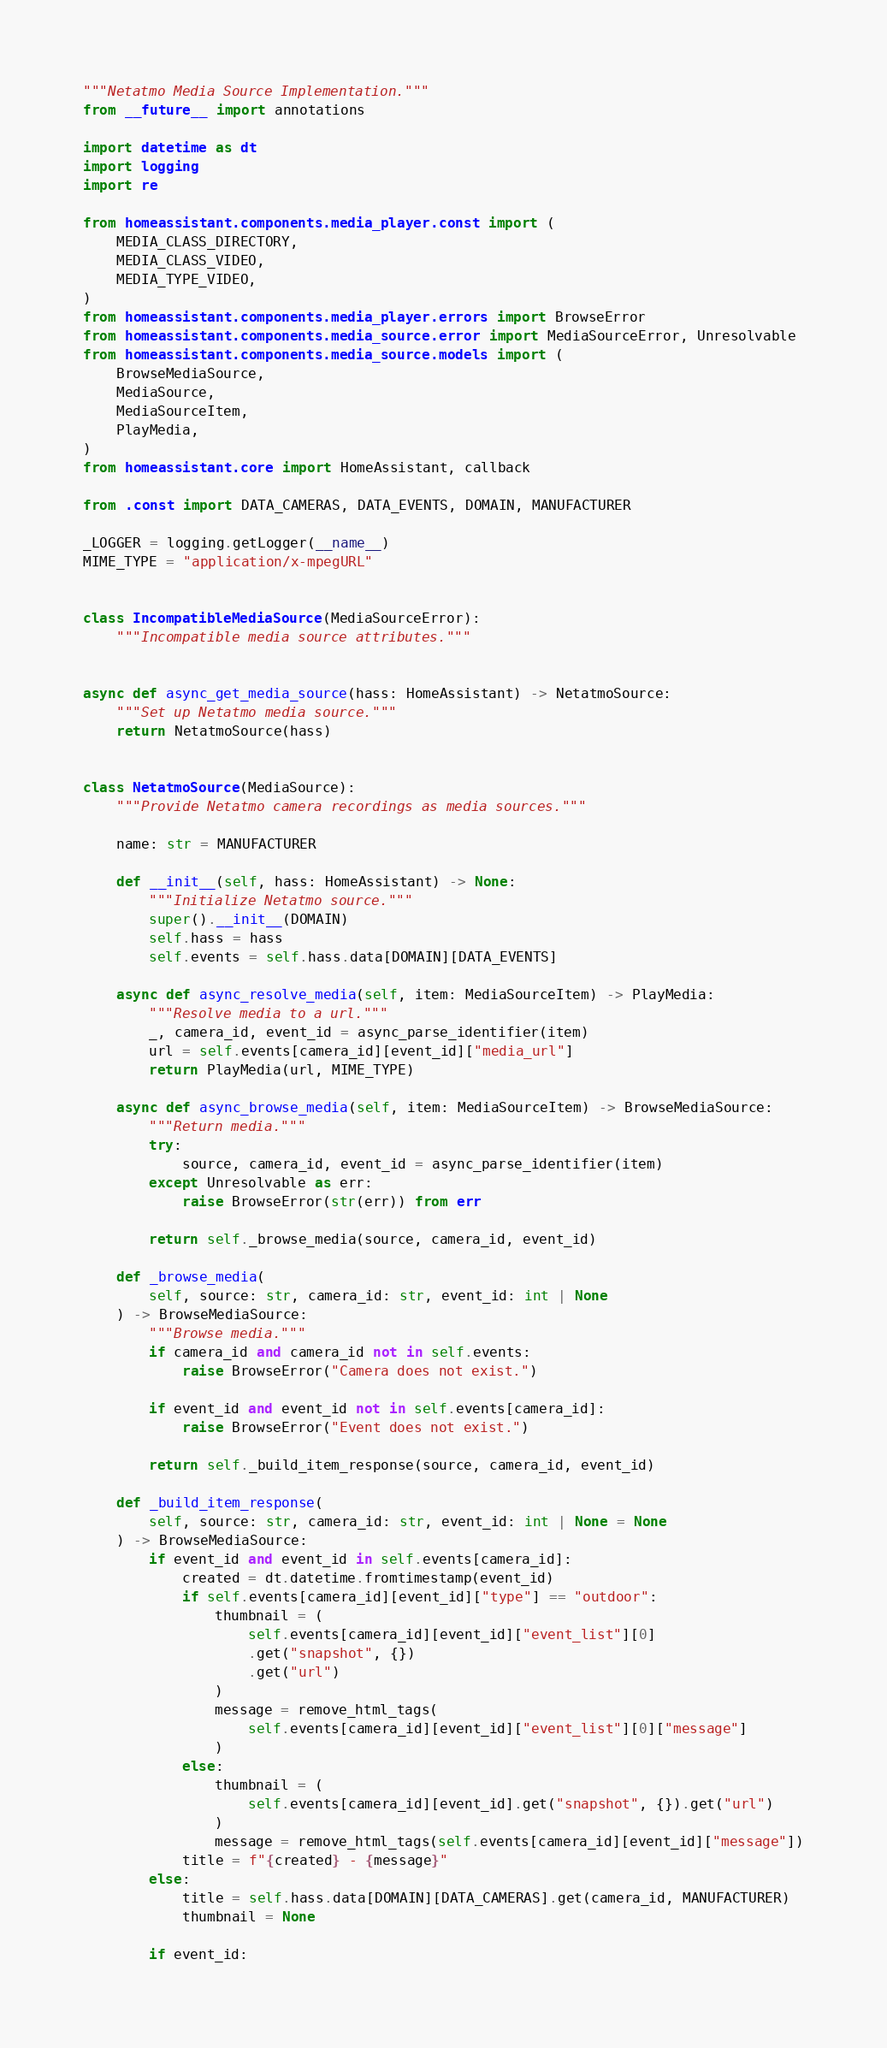<code> <loc_0><loc_0><loc_500><loc_500><_Python_>"""Netatmo Media Source Implementation."""
from __future__ import annotations

import datetime as dt
import logging
import re

from homeassistant.components.media_player.const import (
    MEDIA_CLASS_DIRECTORY,
    MEDIA_CLASS_VIDEO,
    MEDIA_TYPE_VIDEO,
)
from homeassistant.components.media_player.errors import BrowseError
from homeassistant.components.media_source.error import MediaSourceError, Unresolvable
from homeassistant.components.media_source.models import (
    BrowseMediaSource,
    MediaSource,
    MediaSourceItem,
    PlayMedia,
)
from homeassistant.core import HomeAssistant, callback

from .const import DATA_CAMERAS, DATA_EVENTS, DOMAIN, MANUFACTURER

_LOGGER = logging.getLogger(__name__)
MIME_TYPE = "application/x-mpegURL"


class IncompatibleMediaSource(MediaSourceError):
    """Incompatible media source attributes."""


async def async_get_media_source(hass: HomeAssistant) -> NetatmoSource:
    """Set up Netatmo media source."""
    return NetatmoSource(hass)


class NetatmoSource(MediaSource):
    """Provide Netatmo camera recordings as media sources."""

    name: str = MANUFACTURER

    def __init__(self, hass: HomeAssistant) -> None:
        """Initialize Netatmo source."""
        super().__init__(DOMAIN)
        self.hass = hass
        self.events = self.hass.data[DOMAIN][DATA_EVENTS]

    async def async_resolve_media(self, item: MediaSourceItem) -> PlayMedia:
        """Resolve media to a url."""
        _, camera_id, event_id = async_parse_identifier(item)
        url = self.events[camera_id][event_id]["media_url"]
        return PlayMedia(url, MIME_TYPE)

    async def async_browse_media(self, item: MediaSourceItem) -> BrowseMediaSource:
        """Return media."""
        try:
            source, camera_id, event_id = async_parse_identifier(item)
        except Unresolvable as err:
            raise BrowseError(str(err)) from err

        return self._browse_media(source, camera_id, event_id)

    def _browse_media(
        self, source: str, camera_id: str, event_id: int | None
    ) -> BrowseMediaSource:
        """Browse media."""
        if camera_id and camera_id not in self.events:
            raise BrowseError("Camera does not exist.")

        if event_id and event_id not in self.events[camera_id]:
            raise BrowseError("Event does not exist.")

        return self._build_item_response(source, camera_id, event_id)

    def _build_item_response(
        self, source: str, camera_id: str, event_id: int | None = None
    ) -> BrowseMediaSource:
        if event_id and event_id in self.events[camera_id]:
            created = dt.datetime.fromtimestamp(event_id)
            if self.events[camera_id][event_id]["type"] == "outdoor":
                thumbnail = (
                    self.events[camera_id][event_id]["event_list"][0]
                    .get("snapshot", {})
                    .get("url")
                )
                message = remove_html_tags(
                    self.events[camera_id][event_id]["event_list"][0]["message"]
                )
            else:
                thumbnail = (
                    self.events[camera_id][event_id].get("snapshot", {}).get("url")
                )
                message = remove_html_tags(self.events[camera_id][event_id]["message"])
            title = f"{created} - {message}"
        else:
            title = self.hass.data[DOMAIN][DATA_CAMERAS].get(camera_id, MANUFACTURER)
            thumbnail = None

        if event_id:</code> 